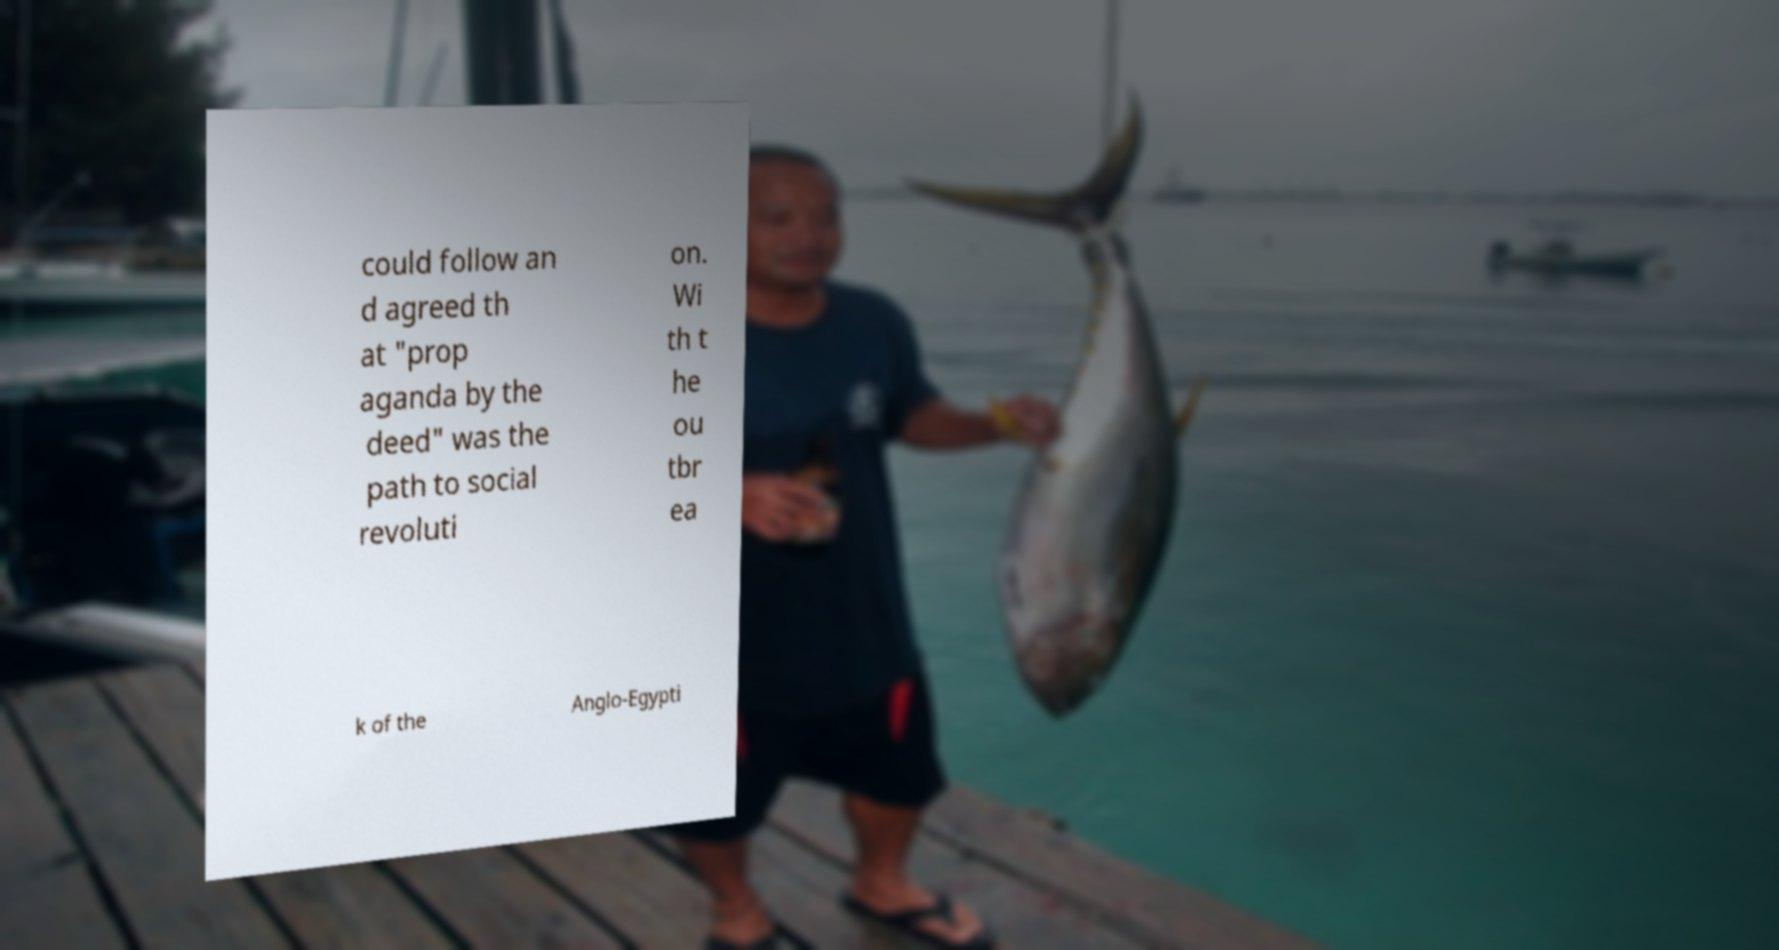Can you accurately transcribe the text from the provided image for me? could follow an d agreed th at "prop aganda by the deed" was the path to social revoluti on. Wi th t he ou tbr ea k of the Anglo-Egypti 